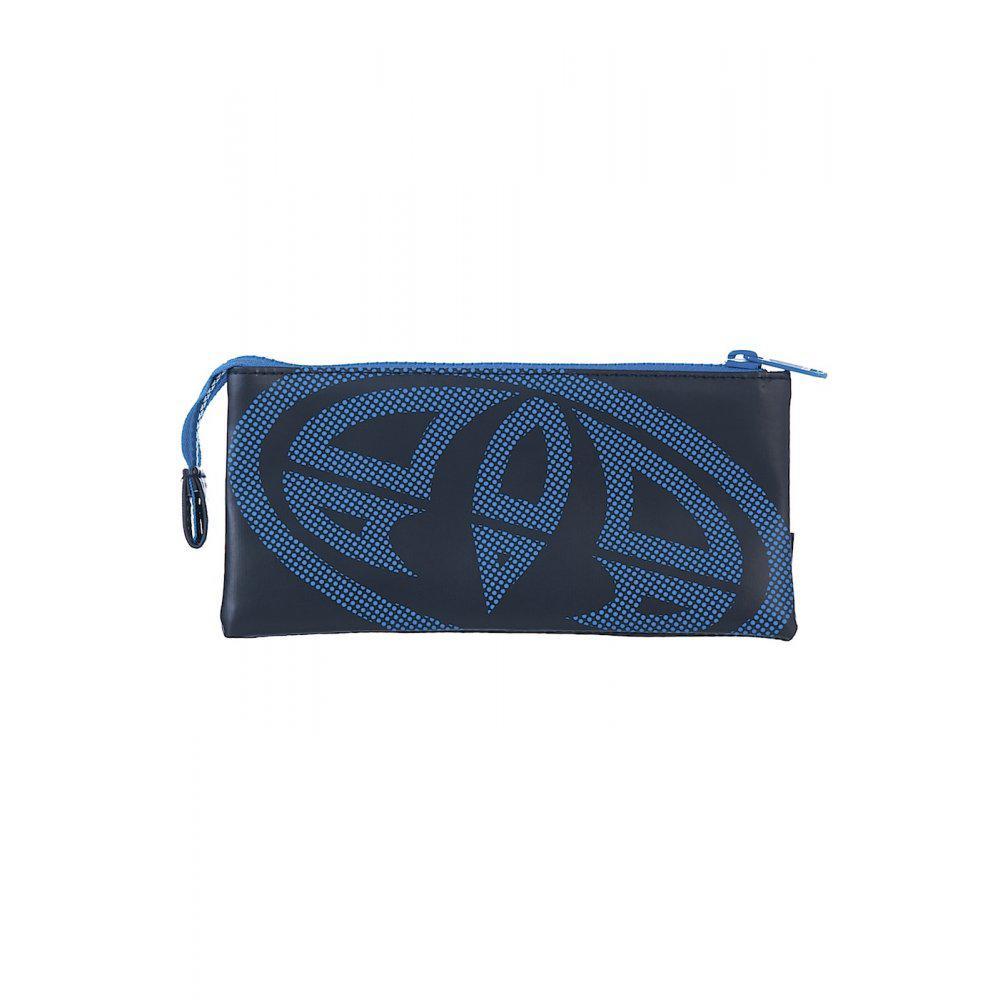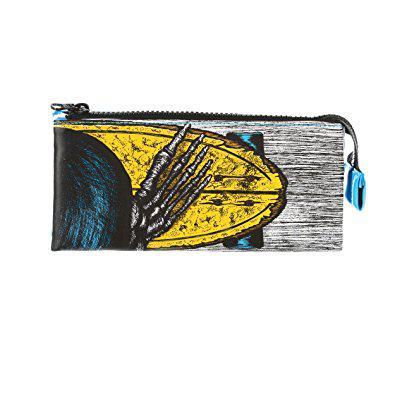The first image is the image on the left, the second image is the image on the right. Examine the images to the left and right. Is the description "Two rectangular shaped closed bags are decorated with different designs, but both have a visible zipper pull at one end and the zipper tag hanging down on the other end." accurate? Answer yes or no. Yes. The first image is the image on the left, the second image is the image on the right. Given the left and right images, does the statement "At least one of the pencil cases is red, and all pencil cases with a visible front feature bold lettering." hold true? Answer yes or no. No. 